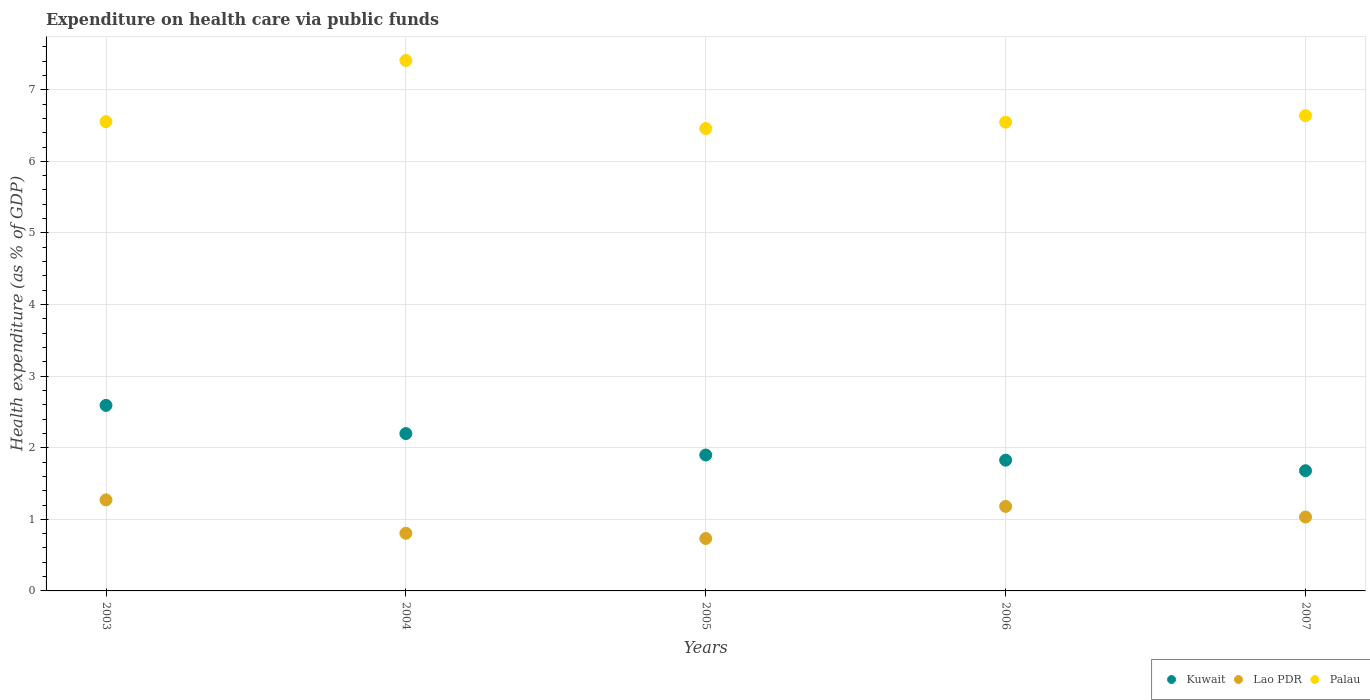How many different coloured dotlines are there?
Your answer should be very brief. 3. Is the number of dotlines equal to the number of legend labels?
Offer a very short reply. Yes. What is the expenditure made on health care in Lao PDR in 2005?
Offer a very short reply. 0.73. Across all years, what is the maximum expenditure made on health care in Lao PDR?
Your response must be concise. 1.27. Across all years, what is the minimum expenditure made on health care in Lao PDR?
Your answer should be very brief. 0.73. In which year was the expenditure made on health care in Kuwait maximum?
Give a very brief answer. 2003. In which year was the expenditure made on health care in Kuwait minimum?
Provide a short and direct response. 2007. What is the total expenditure made on health care in Lao PDR in the graph?
Ensure brevity in your answer.  5.02. What is the difference between the expenditure made on health care in Palau in 2005 and that in 2006?
Offer a terse response. -0.09. What is the difference between the expenditure made on health care in Palau in 2006 and the expenditure made on health care in Kuwait in 2007?
Keep it short and to the point. 4.87. What is the average expenditure made on health care in Kuwait per year?
Offer a terse response. 2.04. In the year 2006, what is the difference between the expenditure made on health care in Lao PDR and expenditure made on health care in Kuwait?
Ensure brevity in your answer.  -0.65. In how many years, is the expenditure made on health care in Kuwait greater than 3.8 %?
Your answer should be compact. 0. What is the ratio of the expenditure made on health care in Palau in 2003 to that in 2007?
Your answer should be very brief. 0.99. What is the difference between the highest and the second highest expenditure made on health care in Lao PDR?
Give a very brief answer. 0.09. What is the difference between the highest and the lowest expenditure made on health care in Lao PDR?
Ensure brevity in your answer.  0.54. In how many years, is the expenditure made on health care in Kuwait greater than the average expenditure made on health care in Kuwait taken over all years?
Your response must be concise. 2. Is the sum of the expenditure made on health care in Lao PDR in 2004 and 2007 greater than the maximum expenditure made on health care in Palau across all years?
Your answer should be compact. No. Is it the case that in every year, the sum of the expenditure made on health care in Palau and expenditure made on health care in Lao PDR  is greater than the expenditure made on health care in Kuwait?
Your answer should be very brief. Yes. Does the expenditure made on health care in Palau monotonically increase over the years?
Keep it short and to the point. No. Is the expenditure made on health care in Lao PDR strictly greater than the expenditure made on health care in Kuwait over the years?
Provide a succinct answer. No. Is the expenditure made on health care in Palau strictly less than the expenditure made on health care in Lao PDR over the years?
Keep it short and to the point. No. How many dotlines are there?
Your answer should be compact. 3. How many years are there in the graph?
Give a very brief answer. 5. What is the difference between two consecutive major ticks on the Y-axis?
Offer a terse response. 1. Are the values on the major ticks of Y-axis written in scientific E-notation?
Give a very brief answer. No. Does the graph contain grids?
Your response must be concise. Yes. How many legend labels are there?
Your response must be concise. 3. How are the legend labels stacked?
Make the answer very short. Horizontal. What is the title of the graph?
Ensure brevity in your answer.  Expenditure on health care via public funds. Does "Congo (Democratic)" appear as one of the legend labels in the graph?
Provide a succinct answer. No. What is the label or title of the X-axis?
Keep it short and to the point. Years. What is the label or title of the Y-axis?
Provide a succinct answer. Health expenditure (as % of GDP). What is the Health expenditure (as % of GDP) in Kuwait in 2003?
Provide a succinct answer. 2.59. What is the Health expenditure (as % of GDP) in Lao PDR in 2003?
Offer a terse response. 1.27. What is the Health expenditure (as % of GDP) of Palau in 2003?
Your response must be concise. 6.56. What is the Health expenditure (as % of GDP) in Kuwait in 2004?
Ensure brevity in your answer.  2.2. What is the Health expenditure (as % of GDP) of Lao PDR in 2004?
Offer a very short reply. 0.81. What is the Health expenditure (as % of GDP) in Palau in 2004?
Your answer should be very brief. 7.41. What is the Health expenditure (as % of GDP) in Kuwait in 2005?
Your answer should be very brief. 1.9. What is the Health expenditure (as % of GDP) in Lao PDR in 2005?
Make the answer very short. 0.73. What is the Health expenditure (as % of GDP) in Palau in 2005?
Your response must be concise. 6.46. What is the Health expenditure (as % of GDP) of Kuwait in 2006?
Your answer should be very brief. 1.83. What is the Health expenditure (as % of GDP) in Lao PDR in 2006?
Make the answer very short. 1.18. What is the Health expenditure (as % of GDP) in Palau in 2006?
Offer a very short reply. 6.55. What is the Health expenditure (as % of GDP) of Kuwait in 2007?
Your response must be concise. 1.68. What is the Health expenditure (as % of GDP) of Lao PDR in 2007?
Your answer should be compact. 1.03. What is the Health expenditure (as % of GDP) of Palau in 2007?
Provide a succinct answer. 6.64. Across all years, what is the maximum Health expenditure (as % of GDP) in Kuwait?
Give a very brief answer. 2.59. Across all years, what is the maximum Health expenditure (as % of GDP) in Lao PDR?
Offer a terse response. 1.27. Across all years, what is the maximum Health expenditure (as % of GDP) in Palau?
Keep it short and to the point. 7.41. Across all years, what is the minimum Health expenditure (as % of GDP) in Kuwait?
Offer a terse response. 1.68. Across all years, what is the minimum Health expenditure (as % of GDP) in Lao PDR?
Your answer should be compact. 0.73. Across all years, what is the minimum Health expenditure (as % of GDP) of Palau?
Offer a very short reply. 6.46. What is the total Health expenditure (as % of GDP) in Kuwait in the graph?
Your answer should be very brief. 10.19. What is the total Health expenditure (as % of GDP) in Lao PDR in the graph?
Keep it short and to the point. 5.02. What is the total Health expenditure (as % of GDP) in Palau in the graph?
Ensure brevity in your answer.  33.61. What is the difference between the Health expenditure (as % of GDP) in Kuwait in 2003 and that in 2004?
Provide a short and direct response. 0.39. What is the difference between the Health expenditure (as % of GDP) in Lao PDR in 2003 and that in 2004?
Offer a terse response. 0.47. What is the difference between the Health expenditure (as % of GDP) in Palau in 2003 and that in 2004?
Your answer should be compact. -0.85. What is the difference between the Health expenditure (as % of GDP) in Kuwait in 2003 and that in 2005?
Give a very brief answer. 0.69. What is the difference between the Health expenditure (as % of GDP) of Lao PDR in 2003 and that in 2005?
Provide a short and direct response. 0.54. What is the difference between the Health expenditure (as % of GDP) of Palau in 2003 and that in 2005?
Your answer should be very brief. 0.1. What is the difference between the Health expenditure (as % of GDP) in Kuwait in 2003 and that in 2006?
Offer a very short reply. 0.77. What is the difference between the Health expenditure (as % of GDP) of Lao PDR in 2003 and that in 2006?
Make the answer very short. 0.09. What is the difference between the Health expenditure (as % of GDP) in Palau in 2003 and that in 2006?
Give a very brief answer. 0.01. What is the difference between the Health expenditure (as % of GDP) in Kuwait in 2003 and that in 2007?
Your answer should be compact. 0.91. What is the difference between the Health expenditure (as % of GDP) in Lao PDR in 2003 and that in 2007?
Offer a very short reply. 0.24. What is the difference between the Health expenditure (as % of GDP) in Palau in 2003 and that in 2007?
Provide a short and direct response. -0.08. What is the difference between the Health expenditure (as % of GDP) of Kuwait in 2004 and that in 2005?
Give a very brief answer. 0.3. What is the difference between the Health expenditure (as % of GDP) of Lao PDR in 2004 and that in 2005?
Make the answer very short. 0.07. What is the difference between the Health expenditure (as % of GDP) in Palau in 2004 and that in 2005?
Your answer should be compact. 0.95. What is the difference between the Health expenditure (as % of GDP) in Kuwait in 2004 and that in 2006?
Your answer should be compact. 0.37. What is the difference between the Health expenditure (as % of GDP) in Lao PDR in 2004 and that in 2006?
Provide a short and direct response. -0.38. What is the difference between the Health expenditure (as % of GDP) of Palau in 2004 and that in 2006?
Offer a very short reply. 0.86. What is the difference between the Health expenditure (as % of GDP) of Kuwait in 2004 and that in 2007?
Your answer should be compact. 0.52. What is the difference between the Health expenditure (as % of GDP) in Lao PDR in 2004 and that in 2007?
Make the answer very short. -0.23. What is the difference between the Health expenditure (as % of GDP) in Palau in 2004 and that in 2007?
Give a very brief answer. 0.77. What is the difference between the Health expenditure (as % of GDP) of Kuwait in 2005 and that in 2006?
Provide a short and direct response. 0.07. What is the difference between the Health expenditure (as % of GDP) of Lao PDR in 2005 and that in 2006?
Offer a very short reply. -0.45. What is the difference between the Health expenditure (as % of GDP) in Palau in 2005 and that in 2006?
Ensure brevity in your answer.  -0.09. What is the difference between the Health expenditure (as % of GDP) in Kuwait in 2005 and that in 2007?
Ensure brevity in your answer.  0.22. What is the difference between the Health expenditure (as % of GDP) of Lao PDR in 2005 and that in 2007?
Ensure brevity in your answer.  -0.3. What is the difference between the Health expenditure (as % of GDP) in Palau in 2005 and that in 2007?
Ensure brevity in your answer.  -0.18. What is the difference between the Health expenditure (as % of GDP) of Kuwait in 2006 and that in 2007?
Your answer should be very brief. 0.15. What is the difference between the Health expenditure (as % of GDP) in Lao PDR in 2006 and that in 2007?
Ensure brevity in your answer.  0.15. What is the difference between the Health expenditure (as % of GDP) of Palau in 2006 and that in 2007?
Offer a terse response. -0.09. What is the difference between the Health expenditure (as % of GDP) in Kuwait in 2003 and the Health expenditure (as % of GDP) in Lao PDR in 2004?
Keep it short and to the point. 1.79. What is the difference between the Health expenditure (as % of GDP) of Kuwait in 2003 and the Health expenditure (as % of GDP) of Palau in 2004?
Your answer should be compact. -4.82. What is the difference between the Health expenditure (as % of GDP) of Lao PDR in 2003 and the Health expenditure (as % of GDP) of Palau in 2004?
Provide a short and direct response. -6.14. What is the difference between the Health expenditure (as % of GDP) of Kuwait in 2003 and the Health expenditure (as % of GDP) of Lao PDR in 2005?
Ensure brevity in your answer.  1.86. What is the difference between the Health expenditure (as % of GDP) in Kuwait in 2003 and the Health expenditure (as % of GDP) in Palau in 2005?
Make the answer very short. -3.87. What is the difference between the Health expenditure (as % of GDP) of Lao PDR in 2003 and the Health expenditure (as % of GDP) of Palau in 2005?
Offer a very short reply. -5.19. What is the difference between the Health expenditure (as % of GDP) in Kuwait in 2003 and the Health expenditure (as % of GDP) in Lao PDR in 2006?
Your response must be concise. 1.41. What is the difference between the Health expenditure (as % of GDP) of Kuwait in 2003 and the Health expenditure (as % of GDP) of Palau in 2006?
Offer a terse response. -3.96. What is the difference between the Health expenditure (as % of GDP) in Lao PDR in 2003 and the Health expenditure (as % of GDP) in Palau in 2006?
Offer a terse response. -5.28. What is the difference between the Health expenditure (as % of GDP) in Kuwait in 2003 and the Health expenditure (as % of GDP) in Lao PDR in 2007?
Keep it short and to the point. 1.56. What is the difference between the Health expenditure (as % of GDP) of Kuwait in 2003 and the Health expenditure (as % of GDP) of Palau in 2007?
Your answer should be compact. -4.05. What is the difference between the Health expenditure (as % of GDP) in Lao PDR in 2003 and the Health expenditure (as % of GDP) in Palau in 2007?
Your answer should be compact. -5.37. What is the difference between the Health expenditure (as % of GDP) in Kuwait in 2004 and the Health expenditure (as % of GDP) in Lao PDR in 2005?
Your response must be concise. 1.47. What is the difference between the Health expenditure (as % of GDP) of Kuwait in 2004 and the Health expenditure (as % of GDP) of Palau in 2005?
Provide a short and direct response. -4.26. What is the difference between the Health expenditure (as % of GDP) in Lao PDR in 2004 and the Health expenditure (as % of GDP) in Palau in 2005?
Your answer should be compact. -5.65. What is the difference between the Health expenditure (as % of GDP) of Kuwait in 2004 and the Health expenditure (as % of GDP) of Lao PDR in 2006?
Ensure brevity in your answer.  1.02. What is the difference between the Health expenditure (as % of GDP) of Kuwait in 2004 and the Health expenditure (as % of GDP) of Palau in 2006?
Offer a terse response. -4.35. What is the difference between the Health expenditure (as % of GDP) in Lao PDR in 2004 and the Health expenditure (as % of GDP) in Palau in 2006?
Keep it short and to the point. -5.74. What is the difference between the Health expenditure (as % of GDP) in Kuwait in 2004 and the Health expenditure (as % of GDP) in Lao PDR in 2007?
Make the answer very short. 1.17. What is the difference between the Health expenditure (as % of GDP) in Kuwait in 2004 and the Health expenditure (as % of GDP) in Palau in 2007?
Your response must be concise. -4.44. What is the difference between the Health expenditure (as % of GDP) in Lao PDR in 2004 and the Health expenditure (as % of GDP) in Palau in 2007?
Your response must be concise. -5.83. What is the difference between the Health expenditure (as % of GDP) in Kuwait in 2005 and the Health expenditure (as % of GDP) in Lao PDR in 2006?
Give a very brief answer. 0.72. What is the difference between the Health expenditure (as % of GDP) in Kuwait in 2005 and the Health expenditure (as % of GDP) in Palau in 2006?
Offer a very short reply. -4.65. What is the difference between the Health expenditure (as % of GDP) of Lao PDR in 2005 and the Health expenditure (as % of GDP) of Palau in 2006?
Provide a succinct answer. -5.82. What is the difference between the Health expenditure (as % of GDP) of Kuwait in 2005 and the Health expenditure (as % of GDP) of Lao PDR in 2007?
Provide a short and direct response. 0.87. What is the difference between the Health expenditure (as % of GDP) of Kuwait in 2005 and the Health expenditure (as % of GDP) of Palau in 2007?
Offer a very short reply. -4.74. What is the difference between the Health expenditure (as % of GDP) of Lao PDR in 2005 and the Health expenditure (as % of GDP) of Palau in 2007?
Make the answer very short. -5.91. What is the difference between the Health expenditure (as % of GDP) in Kuwait in 2006 and the Health expenditure (as % of GDP) in Lao PDR in 2007?
Offer a very short reply. 0.79. What is the difference between the Health expenditure (as % of GDP) in Kuwait in 2006 and the Health expenditure (as % of GDP) in Palau in 2007?
Your response must be concise. -4.81. What is the difference between the Health expenditure (as % of GDP) in Lao PDR in 2006 and the Health expenditure (as % of GDP) in Palau in 2007?
Provide a succinct answer. -5.46. What is the average Health expenditure (as % of GDP) of Kuwait per year?
Provide a short and direct response. 2.04. What is the average Health expenditure (as % of GDP) in Lao PDR per year?
Offer a terse response. 1. What is the average Health expenditure (as % of GDP) of Palau per year?
Give a very brief answer. 6.72. In the year 2003, what is the difference between the Health expenditure (as % of GDP) of Kuwait and Health expenditure (as % of GDP) of Lao PDR?
Keep it short and to the point. 1.32. In the year 2003, what is the difference between the Health expenditure (as % of GDP) in Kuwait and Health expenditure (as % of GDP) in Palau?
Provide a succinct answer. -3.96. In the year 2003, what is the difference between the Health expenditure (as % of GDP) of Lao PDR and Health expenditure (as % of GDP) of Palau?
Give a very brief answer. -5.28. In the year 2004, what is the difference between the Health expenditure (as % of GDP) in Kuwait and Health expenditure (as % of GDP) in Lao PDR?
Give a very brief answer. 1.39. In the year 2004, what is the difference between the Health expenditure (as % of GDP) in Kuwait and Health expenditure (as % of GDP) in Palau?
Offer a very short reply. -5.21. In the year 2004, what is the difference between the Health expenditure (as % of GDP) of Lao PDR and Health expenditure (as % of GDP) of Palau?
Your response must be concise. -6.6. In the year 2005, what is the difference between the Health expenditure (as % of GDP) in Kuwait and Health expenditure (as % of GDP) in Lao PDR?
Offer a very short reply. 1.17. In the year 2005, what is the difference between the Health expenditure (as % of GDP) of Kuwait and Health expenditure (as % of GDP) of Palau?
Your answer should be compact. -4.56. In the year 2005, what is the difference between the Health expenditure (as % of GDP) in Lao PDR and Health expenditure (as % of GDP) in Palau?
Ensure brevity in your answer.  -5.73. In the year 2006, what is the difference between the Health expenditure (as % of GDP) of Kuwait and Health expenditure (as % of GDP) of Lao PDR?
Your answer should be very brief. 0.65. In the year 2006, what is the difference between the Health expenditure (as % of GDP) in Kuwait and Health expenditure (as % of GDP) in Palau?
Your response must be concise. -4.72. In the year 2006, what is the difference between the Health expenditure (as % of GDP) of Lao PDR and Health expenditure (as % of GDP) of Palau?
Provide a succinct answer. -5.37. In the year 2007, what is the difference between the Health expenditure (as % of GDP) in Kuwait and Health expenditure (as % of GDP) in Lao PDR?
Make the answer very short. 0.65. In the year 2007, what is the difference between the Health expenditure (as % of GDP) in Kuwait and Health expenditure (as % of GDP) in Palau?
Offer a very short reply. -4.96. In the year 2007, what is the difference between the Health expenditure (as % of GDP) in Lao PDR and Health expenditure (as % of GDP) in Palau?
Your response must be concise. -5.61. What is the ratio of the Health expenditure (as % of GDP) in Kuwait in 2003 to that in 2004?
Your response must be concise. 1.18. What is the ratio of the Health expenditure (as % of GDP) in Lao PDR in 2003 to that in 2004?
Your answer should be very brief. 1.58. What is the ratio of the Health expenditure (as % of GDP) in Palau in 2003 to that in 2004?
Provide a short and direct response. 0.88. What is the ratio of the Health expenditure (as % of GDP) in Kuwait in 2003 to that in 2005?
Provide a short and direct response. 1.37. What is the ratio of the Health expenditure (as % of GDP) of Lao PDR in 2003 to that in 2005?
Give a very brief answer. 1.74. What is the ratio of the Health expenditure (as % of GDP) in Kuwait in 2003 to that in 2006?
Provide a short and direct response. 1.42. What is the ratio of the Health expenditure (as % of GDP) of Lao PDR in 2003 to that in 2006?
Provide a short and direct response. 1.08. What is the ratio of the Health expenditure (as % of GDP) in Kuwait in 2003 to that in 2007?
Provide a succinct answer. 1.54. What is the ratio of the Health expenditure (as % of GDP) of Lao PDR in 2003 to that in 2007?
Ensure brevity in your answer.  1.23. What is the ratio of the Health expenditure (as % of GDP) in Palau in 2003 to that in 2007?
Offer a terse response. 0.99. What is the ratio of the Health expenditure (as % of GDP) of Kuwait in 2004 to that in 2005?
Keep it short and to the point. 1.16. What is the ratio of the Health expenditure (as % of GDP) of Lao PDR in 2004 to that in 2005?
Provide a succinct answer. 1.1. What is the ratio of the Health expenditure (as % of GDP) in Palau in 2004 to that in 2005?
Provide a succinct answer. 1.15. What is the ratio of the Health expenditure (as % of GDP) in Kuwait in 2004 to that in 2006?
Your response must be concise. 1.2. What is the ratio of the Health expenditure (as % of GDP) in Lao PDR in 2004 to that in 2006?
Give a very brief answer. 0.68. What is the ratio of the Health expenditure (as % of GDP) of Palau in 2004 to that in 2006?
Make the answer very short. 1.13. What is the ratio of the Health expenditure (as % of GDP) of Kuwait in 2004 to that in 2007?
Offer a very short reply. 1.31. What is the ratio of the Health expenditure (as % of GDP) in Lao PDR in 2004 to that in 2007?
Offer a very short reply. 0.78. What is the ratio of the Health expenditure (as % of GDP) of Palau in 2004 to that in 2007?
Provide a short and direct response. 1.12. What is the ratio of the Health expenditure (as % of GDP) of Kuwait in 2005 to that in 2006?
Make the answer very short. 1.04. What is the ratio of the Health expenditure (as % of GDP) in Lao PDR in 2005 to that in 2006?
Give a very brief answer. 0.62. What is the ratio of the Health expenditure (as % of GDP) in Palau in 2005 to that in 2006?
Offer a terse response. 0.99. What is the ratio of the Health expenditure (as % of GDP) in Kuwait in 2005 to that in 2007?
Provide a short and direct response. 1.13. What is the ratio of the Health expenditure (as % of GDP) in Lao PDR in 2005 to that in 2007?
Give a very brief answer. 0.71. What is the ratio of the Health expenditure (as % of GDP) in Kuwait in 2006 to that in 2007?
Offer a terse response. 1.09. What is the ratio of the Health expenditure (as % of GDP) of Lao PDR in 2006 to that in 2007?
Your answer should be very brief. 1.14. What is the ratio of the Health expenditure (as % of GDP) in Palau in 2006 to that in 2007?
Your response must be concise. 0.99. What is the difference between the highest and the second highest Health expenditure (as % of GDP) of Kuwait?
Your answer should be compact. 0.39. What is the difference between the highest and the second highest Health expenditure (as % of GDP) of Lao PDR?
Make the answer very short. 0.09. What is the difference between the highest and the second highest Health expenditure (as % of GDP) in Palau?
Your answer should be compact. 0.77. What is the difference between the highest and the lowest Health expenditure (as % of GDP) in Kuwait?
Provide a succinct answer. 0.91. What is the difference between the highest and the lowest Health expenditure (as % of GDP) in Lao PDR?
Make the answer very short. 0.54. What is the difference between the highest and the lowest Health expenditure (as % of GDP) in Palau?
Your answer should be very brief. 0.95. 